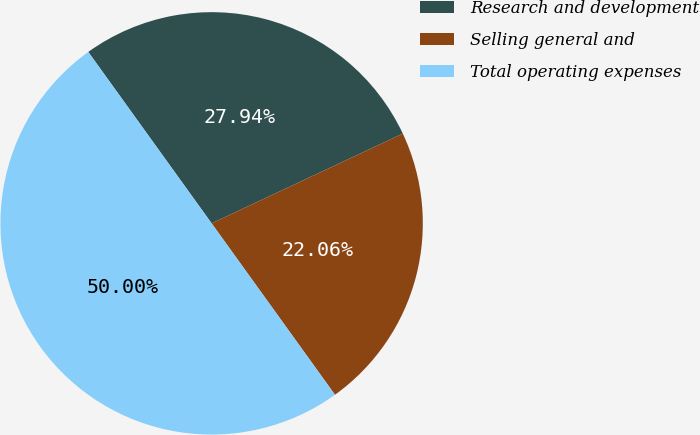<chart> <loc_0><loc_0><loc_500><loc_500><pie_chart><fcel>Research and development<fcel>Selling general and<fcel>Total operating expenses<nl><fcel>27.94%<fcel>22.06%<fcel>50.0%<nl></chart> 